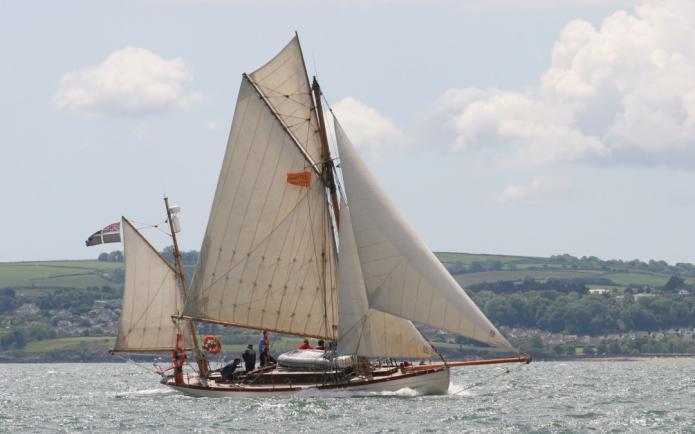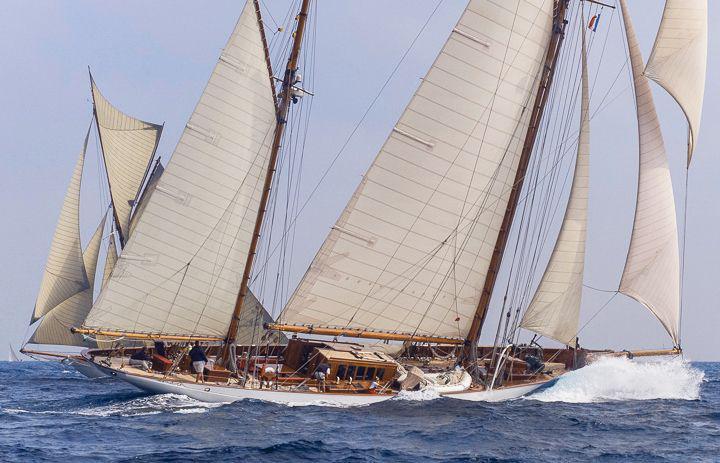The first image is the image on the left, the second image is the image on the right. Analyze the images presented: Is the assertion "The sails are down on at least one of the vessels." valid? Answer yes or no. No. The first image is the image on the left, the second image is the image on the right. Given the left and right images, does the statement "All the boats have their sails up." hold true? Answer yes or no. Yes. 